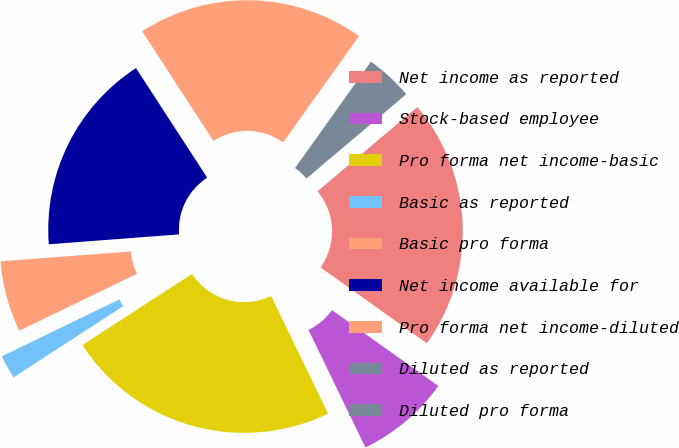Convert chart to OTSL. <chart><loc_0><loc_0><loc_500><loc_500><pie_chart><fcel>Net income as reported<fcel>Stock-based employee<fcel>Pro forma net income-basic<fcel>Basic as reported<fcel>Basic pro forma<fcel>Net income available for<fcel>Pro forma net income-diluted<fcel>Diluted as reported<fcel>Diluted pro forma<nl><fcel>21.02%<fcel>7.96%<fcel>23.01%<fcel>1.99%<fcel>5.97%<fcel>17.04%<fcel>19.03%<fcel>0.0%<fcel>3.98%<nl></chart> 